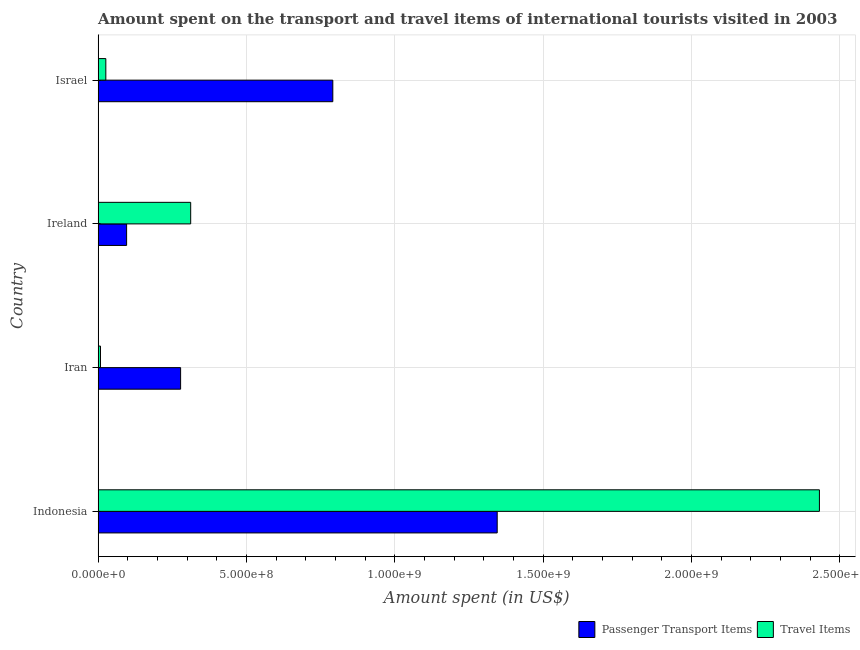How many groups of bars are there?
Your response must be concise. 4. Are the number of bars per tick equal to the number of legend labels?
Provide a succinct answer. Yes. Are the number of bars on each tick of the Y-axis equal?
Provide a short and direct response. Yes. How many bars are there on the 4th tick from the bottom?
Offer a terse response. 2. What is the label of the 1st group of bars from the top?
Keep it short and to the point. Israel. In how many cases, is the number of bars for a given country not equal to the number of legend labels?
Give a very brief answer. 0. What is the amount spent on passenger transport items in Ireland?
Ensure brevity in your answer.  9.60e+07. Across all countries, what is the maximum amount spent on passenger transport items?
Offer a very short reply. 1.34e+09. Across all countries, what is the minimum amount spent on passenger transport items?
Make the answer very short. 9.60e+07. In which country was the amount spent on passenger transport items minimum?
Your answer should be very brief. Ireland. What is the total amount spent on passenger transport items in the graph?
Offer a terse response. 2.51e+09. What is the difference between the amount spent on passenger transport items in Iran and that in Ireland?
Your response must be concise. 1.82e+08. What is the difference between the amount spent in travel items in Iran and the amount spent on passenger transport items in Ireland?
Your answer should be very brief. -8.80e+07. What is the average amount spent on passenger transport items per country?
Your answer should be very brief. 6.28e+08. What is the difference between the amount spent on passenger transport items and amount spent in travel items in Israel?
Offer a terse response. 7.65e+08. In how many countries, is the amount spent on passenger transport items greater than 700000000 US$?
Ensure brevity in your answer.  2. What is the ratio of the amount spent on passenger transport items in Ireland to that in Israel?
Provide a short and direct response. 0.12. What is the difference between the highest and the second highest amount spent on passenger transport items?
Provide a short and direct response. 5.54e+08. What is the difference between the highest and the lowest amount spent on passenger transport items?
Offer a very short reply. 1.25e+09. Is the sum of the amount spent on passenger transport items in Indonesia and Ireland greater than the maximum amount spent in travel items across all countries?
Ensure brevity in your answer.  No. What does the 1st bar from the top in Ireland represents?
Provide a succinct answer. Travel Items. What does the 1st bar from the bottom in Iran represents?
Your answer should be compact. Passenger Transport Items. Are all the bars in the graph horizontal?
Your answer should be very brief. Yes. What is the difference between two consecutive major ticks on the X-axis?
Provide a short and direct response. 5.00e+08. Does the graph contain any zero values?
Your answer should be compact. No. Where does the legend appear in the graph?
Make the answer very short. Bottom right. What is the title of the graph?
Ensure brevity in your answer.  Amount spent on the transport and travel items of international tourists visited in 2003. Does "Ages 15-24" appear as one of the legend labels in the graph?
Your response must be concise. No. What is the label or title of the X-axis?
Make the answer very short. Amount spent (in US$). What is the label or title of the Y-axis?
Keep it short and to the point. Country. What is the Amount spent (in US$) in Passenger Transport Items in Indonesia?
Offer a very short reply. 1.34e+09. What is the Amount spent (in US$) of Travel Items in Indonesia?
Your response must be concise. 2.43e+09. What is the Amount spent (in US$) in Passenger Transport Items in Iran?
Give a very brief answer. 2.78e+08. What is the Amount spent (in US$) of Travel Items in Iran?
Give a very brief answer. 8.00e+06. What is the Amount spent (in US$) in Passenger Transport Items in Ireland?
Your response must be concise. 9.60e+07. What is the Amount spent (in US$) of Travel Items in Ireland?
Your response must be concise. 3.12e+08. What is the Amount spent (in US$) in Passenger Transport Items in Israel?
Give a very brief answer. 7.91e+08. What is the Amount spent (in US$) of Travel Items in Israel?
Your response must be concise. 2.60e+07. Across all countries, what is the maximum Amount spent (in US$) in Passenger Transport Items?
Keep it short and to the point. 1.34e+09. Across all countries, what is the maximum Amount spent (in US$) of Travel Items?
Your answer should be compact. 2.43e+09. Across all countries, what is the minimum Amount spent (in US$) in Passenger Transport Items?
Make the answer very short. 9.60e+07. What is the total Amount spent (in US$) in Passenger Transport Items in the graph?
Give a very brief answer. 2.51e+09. What is the total Amount spent (in US$) in Travel Items in the graph?
Offer a very short reply. 2.78e+09. What is the difference between the Amount spent (in US$) of Passenger Transport Items in Indonesia and that in Iran?
Your answer should be compact. 1.07e+09. What is the difference between the Amount spent (in US$) of Travel Items in Indonesia and that in Iran?
Provide a short and direct response. 2.42e+09. What is the difference between the Amount spent (in US$) of Passenger Transport Items in Indonesia and that in Ireland?
Offer a terse response. 1.25e+09. What is the difference between the Amount spent (in US$) of Travel Items in Indonesia and that in Ireland?
Offer a very short reply. 2.12e+09. What is the difference between the Amount spent (in US$) in Passenger Transport Items in Indonesia and that in Israel?
Give a very brief answer. 5.54e+08. What is the difference between the Amount spent (in US$) in Travel Items in Indonesia and that in Israel?
Your answer should be very brief. 2.40e+09. What is the difference between the Amount spent (in US$) in Passenger Transport Items in Iran and that in Ireland?
Provide a short and direct response. 1.82e+08. What is the difference between the Amount spent (in US$) of Travel Items in Iran and that in Ireland?
Your answer should be very brief. -3.04e+08. What is the difference between the Amount spent (in US$) in Passenger Transport Items in Iran and that in Israel?
Your answer should be compact. -5.13e+08. What is the difference between the Amount spent (in US$) in Travel Items in Iran and that in Israel?
Your response must be concise. -1.80e+07. What is the difference between the Amount spent (in US$) in Passenger Transport Items in Ireland and that in Israel?
Provide a succinct answer. -6.95e+08. What is the difference between the Amount spent (in US$) in Travel Items in Ireland and that in Israel?
Offer a very short reply. 2.86e+08. What is the difference between the Amount spent (in US$) of Passenger Transport Items in Indonesia and the Amount spent (in US$) of Travel Items in Iran?
Give a very brief answer. 1.34e+09. What is the difference between the Amount spent (in US$) of Passenger Transport Items in Indonesia and the Amount spent (in US$) of Travel Items in Ireland?
Provide a succinct answer. 1.03e+09. What is the difference between the Amount spent (in US$) of Passenger Transport Items in Indonesia and the Amount spent (in US$) of Travel Items in Israel?
Keep it short and to the point. 1.32e+09. What is the difference between the Amount spent (in US$) of Passenger Transport Items in Iran and the Amount spent (in US$) of Travel Items in Ireland?
Your answer should be compact. -3.40e+07. What is the difference between the Amount spent (in US$) in Passenger Transport Items in Iran and the Amount spent (in US$) in Travel Items in Israel?
Ensure brevity in your answer.  2.52e+08. What is the difference between the Amount spent (in US$) of Passenger Transport Items in Ireland and the Amount spent (in US$) of Travel Items in Israel?
Ensure brevity in your answer.  7.00e+07. What is the average Amount spent (in US$) in Passenger Transport Items per country?
Provide a succinct answer. 6.28e+08. What is the average Amount spent (in US$) of Travel Items per country?
Keep it short and to the point. 6.94e+08. What is the difference between the Amount spent (in US$) in Passenger Transport Items and Amount spent (in US$) in Travel Items in Indonesia?
Provide a succinct answer. -1.09e+09. What is the difference between the Amount spent (in US$) of Passenger Transport Items and Amount spent (in US$) of Travel Items in Iran?
Your answer should be very brief. 2.70e+08. What is the difference between the Amount spent (in US$) in Passenger Transport Items and Amount spent (in US$) in Travel Items in Ireland?
Your answer should be very brief. -2.16e+08. What is the difference between the Amount spent (in US$) of Passenger Transport Items and Amount spent (in US$) of Travel Items in Israel?
Give a very brief answer. 7.65e+08. What is the ratio of the Amount spent (in US$) of Passenger Transport Items in Indonesia to that in Iran?
Keep it short and to the point. 4.84. What is the ratio of the Amount spent (in US$) in Travel Items in Indonesia to that in Iran?
Offer a terse response. 303.88. What is the ratio of the Amount spent (in US$) of Passenger Transport Items in Indonesia to that in Ireland?
Provide a short and direct response. 14.01. What is the ratio of the Amount spent (in US$) of Travel Items in Indonesia to that in Ireland?
Your answer should be very brief. 7.79. What is the ratio of the Amount spent (in US$) in Passenger Transport Items in Indonesia to that in Israel?
Your response must be concise. 1.7. What is the ratio of the Amount spent (in US$) in Travel Items in Indonesia to that in Israel?
Provide a succinct answer. 93.5. What is the ratio of the Amount spent (in US$) in Passenger Transport Items in Iran to that in Ireland?
Offer a very short reply. 2.9. What is the ratio of the Amount spent (in US$) in Travel Items in Iran to that in Ireland?
Your answer should be compact. 0.03. What is the ratio of the Amount spent (in US$) of Passenger Transport Items in Iran to that in Israel?
Keep it short and to the point. 0.35. What is the ratio of the Amount spent (in US$) of Travel Items in Iran to that in Israel?
Your response must be concise. 0.31. What is the ratio of the Amount spent (in US$) of Passenger Transport Items in Ireland to that in Israel?
Offer a terse response. 0.12. What is the difference between the highest and the second highest Amount spent (in US$) of Passenger Transport Items?
Provide a short and direct response. 5.54e+08. What is the difference between the highest and the second highest Amount spent (in US$) in Travel Items?
Provide a short and direct response. 2.12e+09. What is the difference between the highest and the lowest Amount spent (in US$) in Passenger Transport Items?
Ensure brevity in your answer.  1.25e+09. What is the difference between the highest and the lowest Amount spent (in US$) of Travel Items?
Ensure brevity in your answer.  2.42e+09. 